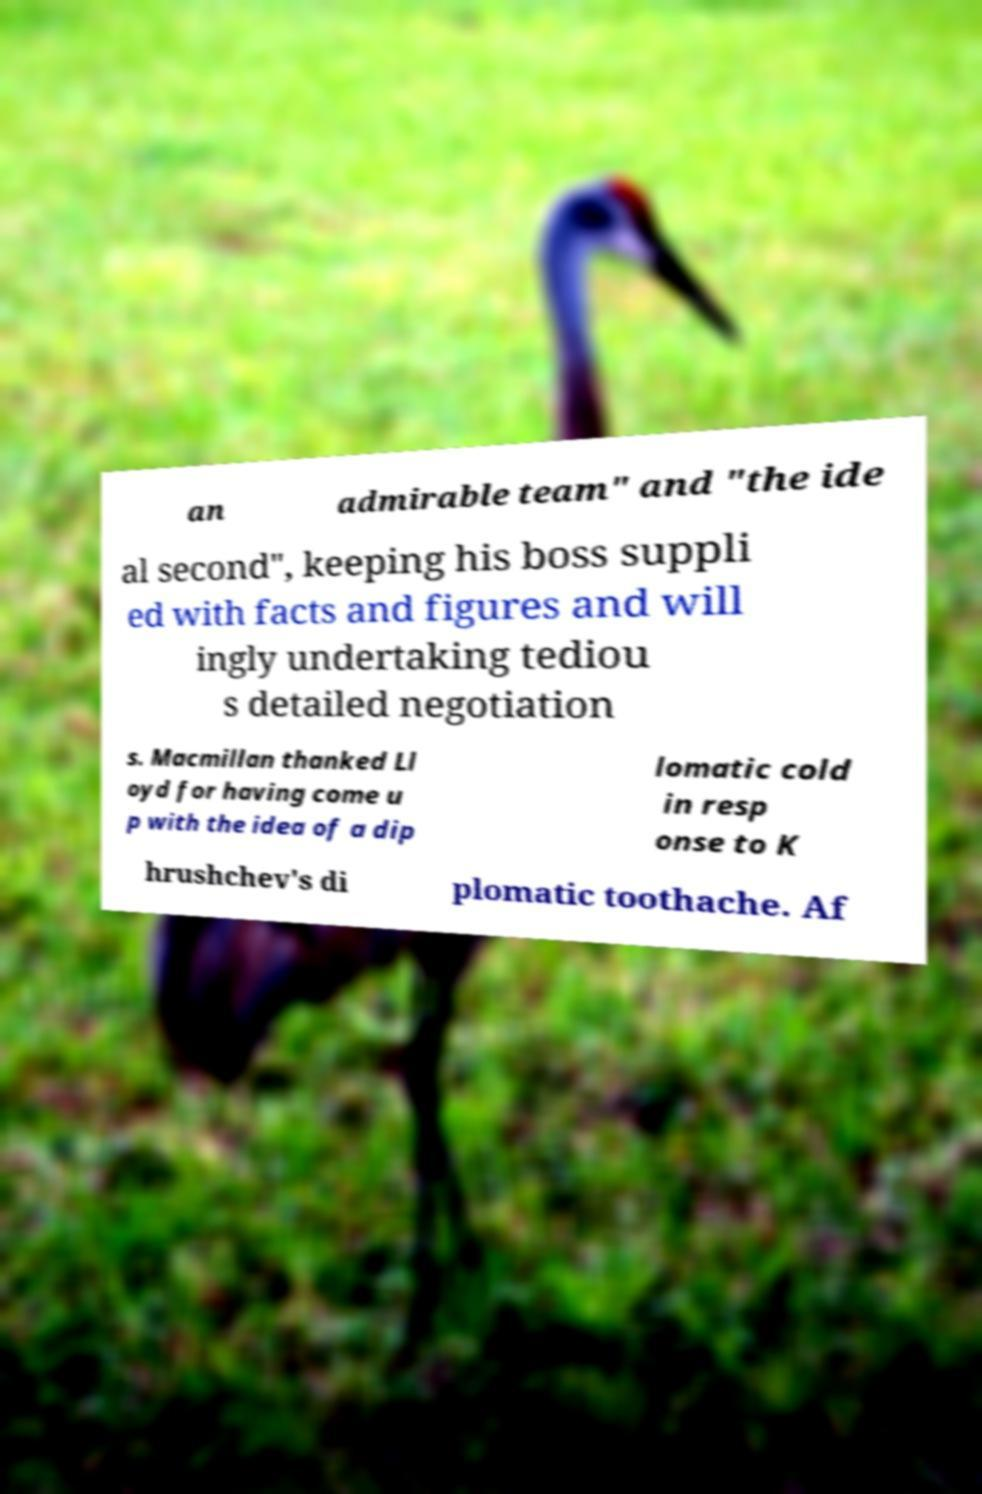Please identify and transcribe the text found in this image. an admirable team" and "the ide al second", keeping his boss suppli ed with facts and figures and will ingly undertaking tediou s detailed negotiation s. Macmillan thanked Ll oyd for having come u p with the idea of a dip lomatic cold in resp onse to K hrushchev's di plomatic toothache. Af 